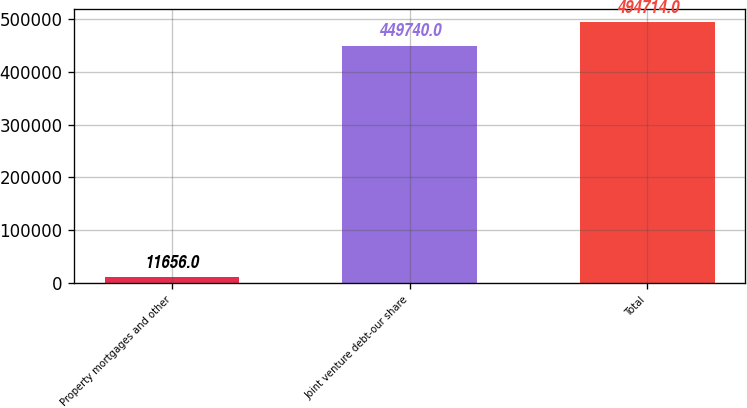<chart> <loc_0><loc_0><loc_500><loc_500><bar_chart><fcel>Property mortgages and other<fcel>Joint venture debt-our share<fcel>Total<nl><fcel>11656<fcel>449740<fcel>494714<nl></chart> 